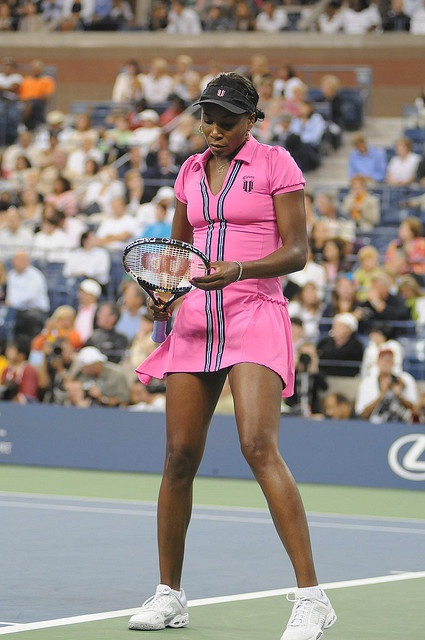Describe the objects in this image and their specific colors. I can see people in maroon, violet, brown, and lightpink tones, tennis racket in maroon, darkgray, lightgray, black, and gray tones, people in maroon, lightgray, gray, darkgray, and tan tones, people in maroon, gray, and darkgray tones, and people in maroon, gray, tan, and salmon tones in this image. 